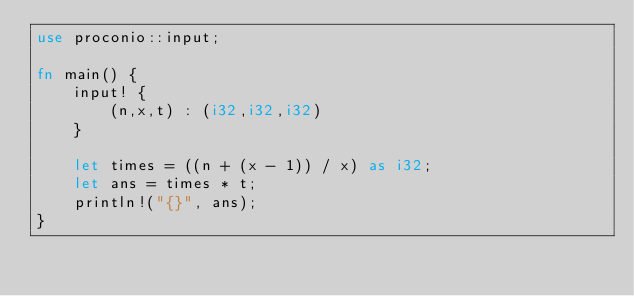Convert code to text. <code><loc_0><loc_0><loc_500><loc_500><_Rust_>use proconio::input;

fn main() {
    input! {
        (n,x,t) : (i32,i32,i32)
    }

    let times = ((n + (x - 1)) / x) as i32;
    let ans = times * t;
    println!("{}", ans);
}
</code> 